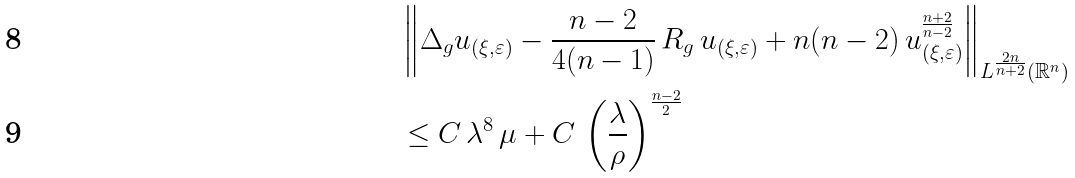<formula> <loc_0><loc_0><loc_500><loc_500>& \left \| \Delta _ { g } u _ { ( \xi , \varepsilon ) } - \frac { n - 2 } { 4 ( n - 1 ) } \, R _ { g } \, u _ { ( \xi , \varepsilon ) } + n ( n - 2 ) \, u _ { ( \xi , \varepsilon ) } ^ { \frac { n + 2 } { n - 2 } } \right \| _ { L ^ { \frac { 2 n } { n + 2 } } ( \mathbb { R } ^ { n } ) } \\ & \leq C \, \lambda ^ { 8 } \, \mu + C \, \left ( \frac { \lambda } { \rho } \right ) ^ { \frac { n - 2 } { 2 } }</formula> 